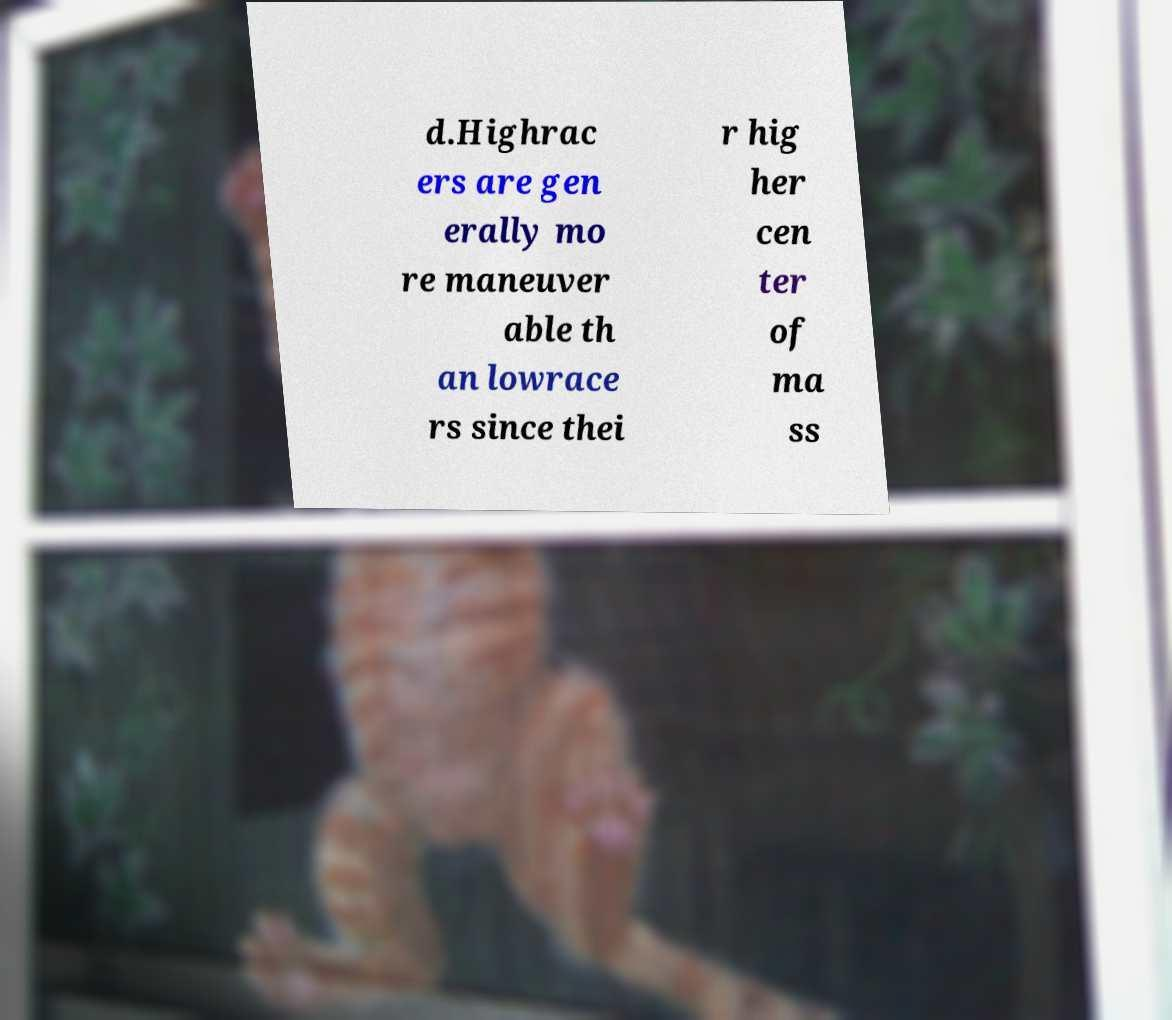For documentation purposes, I need the text within this image transcribed. Could you provide that? d.Highrac ers are gen erally mo re maneuver able th an lowrace rs since thei r hig her cen ter of ma ss 